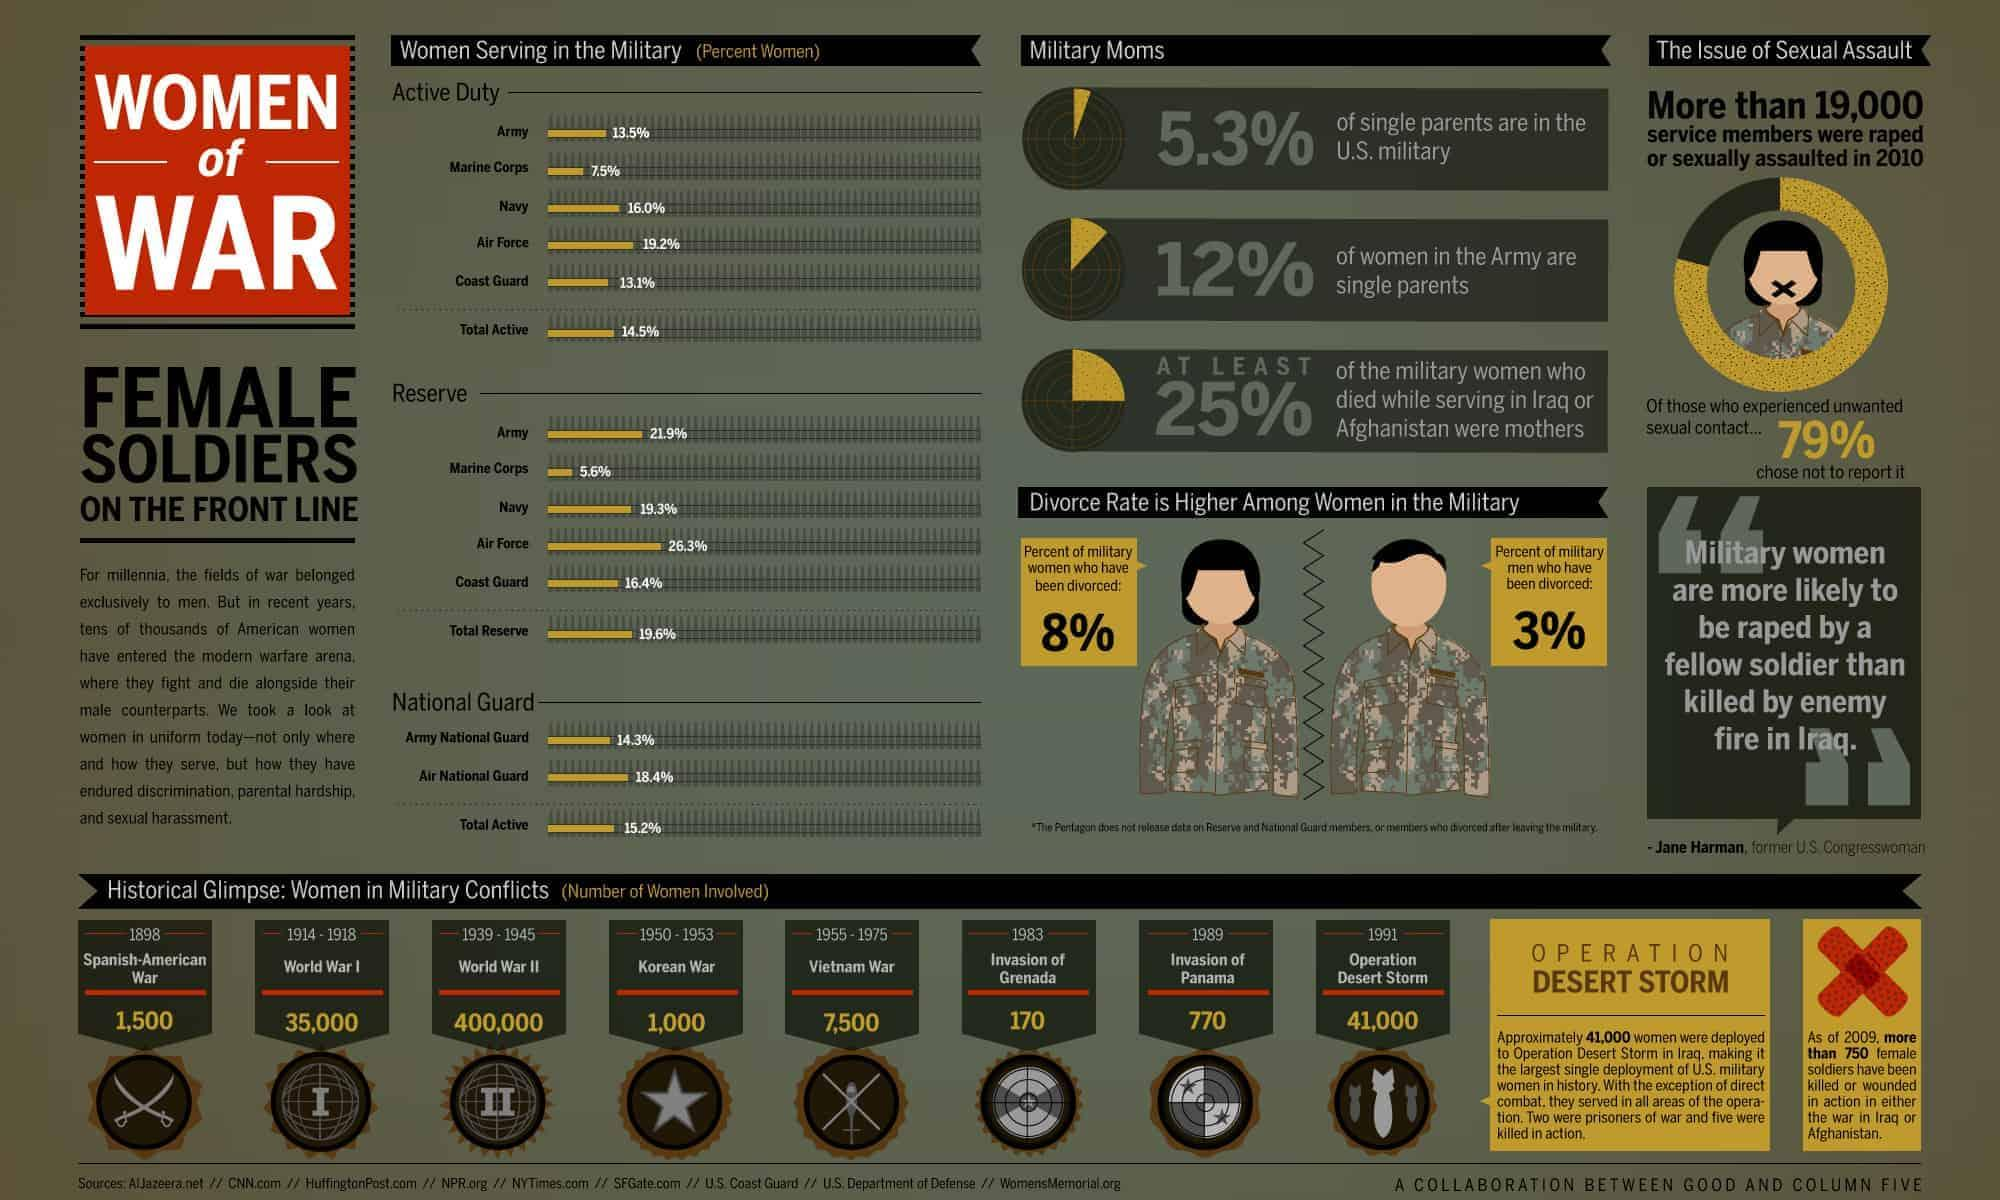Indicate a few pertinent items in this graphic. During World War I, approximately 35,000 American women served in the military, making significant contributions to the war effort. The Vietnam War ended in 1975. According to data, 19.6% of women in the United States serve in the total reserve force. According to data, 16.0% of women serve on active duty in the U.S. Navy. During the Vietnam War, approximately 7,500 American women were involved in the military. 